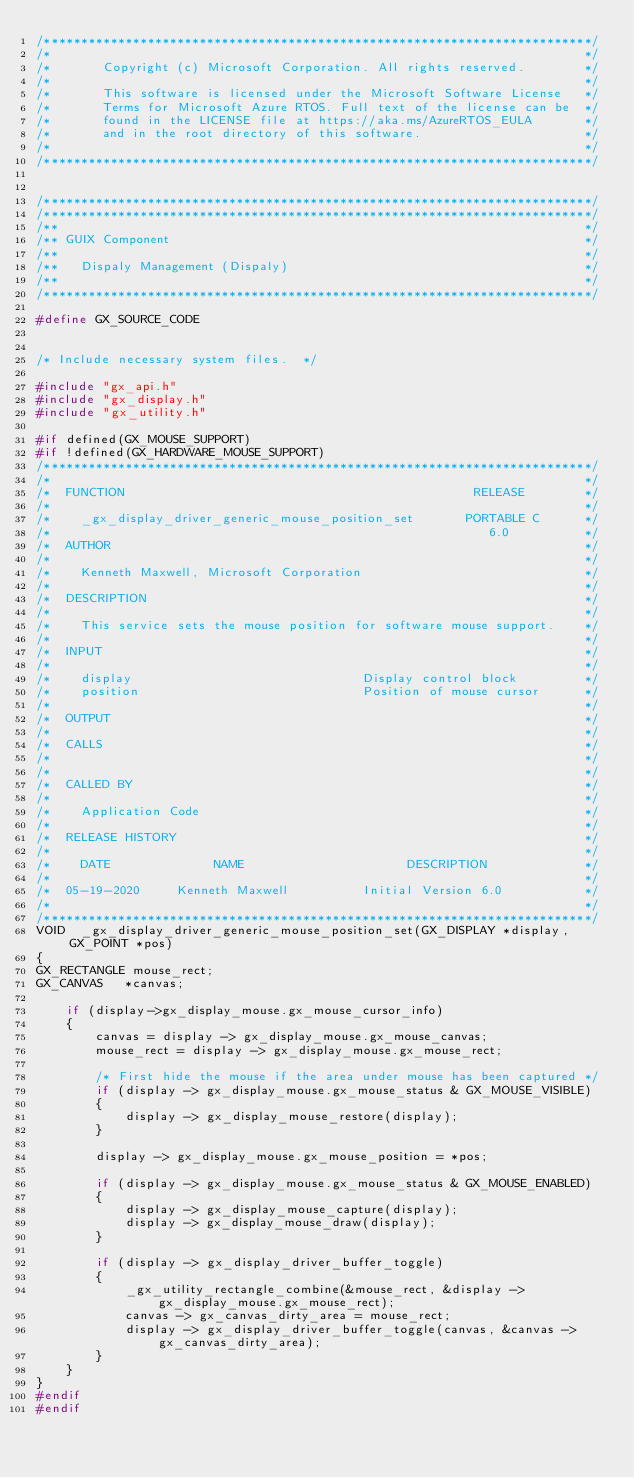Convert code to text. <code><loc_0><loc_0><loc_500><loc_500><_C_>/**************************************************************************/
/*                                                                        */
/*       Copyright (c) Microsoft Corporation. All rights reserved.        */
/*                                                                        */
/*       This software is licensed under the Microsoft Software License   */
/*       Terms for Microsoft Azure RTOS. Full text of the license can be  */
/*       found in the LICENSE file at https://aka.ms/AzureRTOS_EULA       */
/*       and in the root directory of this software.                      */
/*                                                                        */
/**************************************************************************/


/**************************************************************************/
/**************************************************************************/
/**                                                                       */
/** GUIX Component                                                        */
/**                                                                       */
/**   Dispaly Management (Dispaly)                                        */
/**                                                                       */
/**************************************************************************/

#define GX_SOURCE_CODE


/* Include necessary system files.  */

#include "gx_api.h"
#include "gx_display.h"
#include "gx_utility.h"

#if defined(GX_MOUSE_SUPPORT)
#if !defined(GX_HARDWARE_MOUSE_SUPPORT)
/**************************************************************************/
/*                                                                        */
/*  FUNCTION                                               RELEASE        */
/*                                                                        */
/*    _gx_display_driver_generic_mouse_position_set       PORTABLE C      */
/*                                                           6.0          */
/*  AUTHOR                                                                */
/*                                                                        */
/*    Kenneth Maxwell, Microsoft Corporation                              */
/*                                                                        */
/*  DESCRIPTION                                                           */
/*                                                                        */
/*    This service sets the mouse position for software mouse support.    */
/*                                                                        */
/*  INPUT                                                                 */
/*                                                                        */
/*    display                               Display control block         */
/*    position                              Position of mouse cursor      */
/*                                                                        */
/*  OUTPUT                                                                */
/*                                                                        */
/*  CALLS                                                                 */
/*                                                                        */
/*                                                                        */
/*  CALLED BY                                                             */
/*                                                                        */
/*    Application Code                                                    */
/*                                                                        */
/*  RELEASE HISTORY                                                       */
/*                                                                        */
/*    DATE              NAME                      DESCRIPTION             */
/*                                                                        */
/*  05-19-2020     Kenneth Maxwell          Initial Version 6.0           */
/*                                                                        */
/**************************************************************************/
VOID  _gx_display_driver_generic_mouse_position_set(GX_DISPLAY *display, GX_POINT *pos)
{
GX_RECTANGLE mouse_rect;
GX_CANVAS   *canvas;

    if (display->gx_display_mouse.gx_mouse_cursor_info)
    {
        canvas = display -> gx_display_mouse.gx_mouse_canvas;
        mouse_rect = display -> gx_display_mouse.gx_mouse_rect;

        /* First hide the mouse if the area under mouse has been captured */
        if (display -> gx_display_mouse.gx_mouse_status & GX_MOUSE_VISIBLE)
        {
            display -> gx_display_mouse_restore(display);
        }

        display -> gx_display_mouse.gx_mouse_position = *pos;

        if (display -> gx_display_mouse.gx_mouse_status & GX_MOUSE_ENABLED)
        {
            display -> gx_display_mouse_capture(display);
            display -> gx_display_mouse_draw(display);
        }

        if (display -> gx_display_driver_buffer_toggle)
        {
            _gx_utility_rectangle_combine(&mouse_rect, &display -> gx_display_mouse.gx_mouse_rect);
            canvas -> gx_canvas_dirty_area = mouse_rect;
            display -> gx_display_driver_buffer_toggle(canvas, &canvas -> gx_canvas_dirty_area);
        }
    }
}
#endif
#endif

</code> 